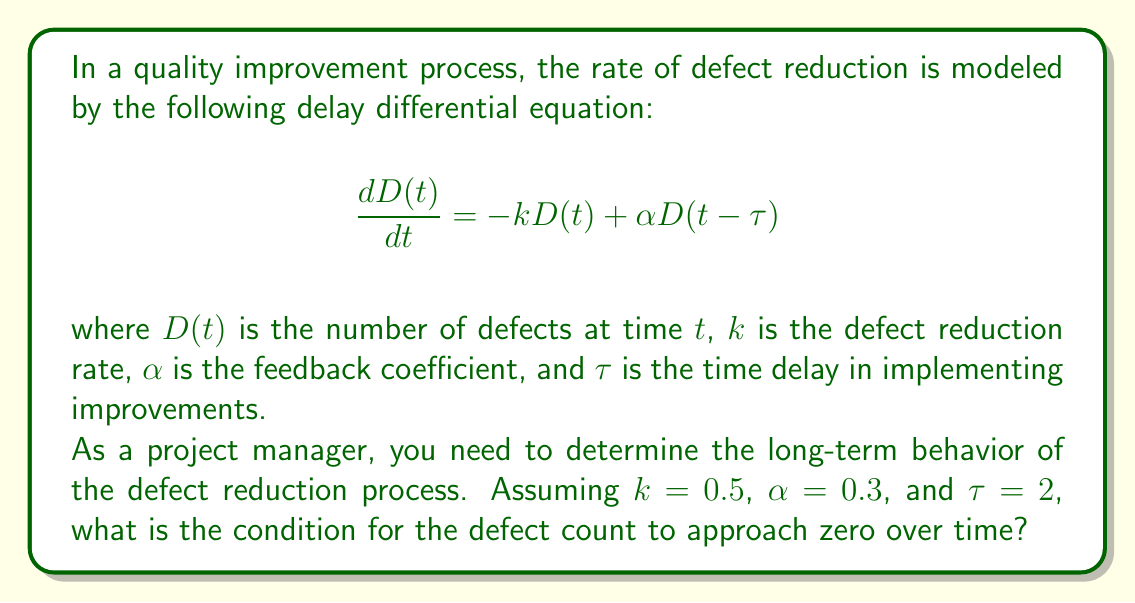Solve this math problem. To analyze the long-term behavior of the delay differential equation, we need to examine its characteristic equation. The general approach is as follows:

1) Assume a solution of the form $D(t) = e^{\lambda t}$, where $\lambda$ is a complex number.

2) Substitute this solution into the original equation:

   $$\lambda e^{\lambda t} = -k e^{\lambda t} + \alpha e^{\lambda(t-\tau)}$$

3) Simplify by dividing both sides by $e^{\lambda t}$:

   $$\lambda = -k + \alpha e^{-\lambda\tau}$$

4) This is the characteristic equation. For the defect count to approach zero over time, all roots of this equation must have negative real parts.

5) Substituting the given values:

   $$\lambda = -0.5 + 0.3e^{-2\lambda}$$

6) This transcendental equation cannot be solved algebraically. However, we can use the following theorem:

   For the equation $\lambda = -k + \alpha e^{-\lambda\tau}$, all roots have negative real parts if and only if:

   $$k\tau < 1 + \frac{\pi}{2} \quad \text{and} \quad k > |\alpha|$$

7) Checking these conditions with our values:

   $k\tau = 0.5 \cdot 2 = 1 < 1 + \frac{\pi}{2}$ (satisfied)
   $k = 0.5 > |\alpha| = 0.3$ (satisfied)

Therefore, both conditions are met, and the defect count will approach zero over time.
Answer: The condition for the defect count to approach zero over time is satisfied when $k\tau < 1 + \frac{\pi}{2}$ and $k > |\alpha|$. With the given values $k = 0.5$, $\alpha = 0.3$, and $\tau = 2$, both conditions are met, so the defect count will approach zero in the long term. 